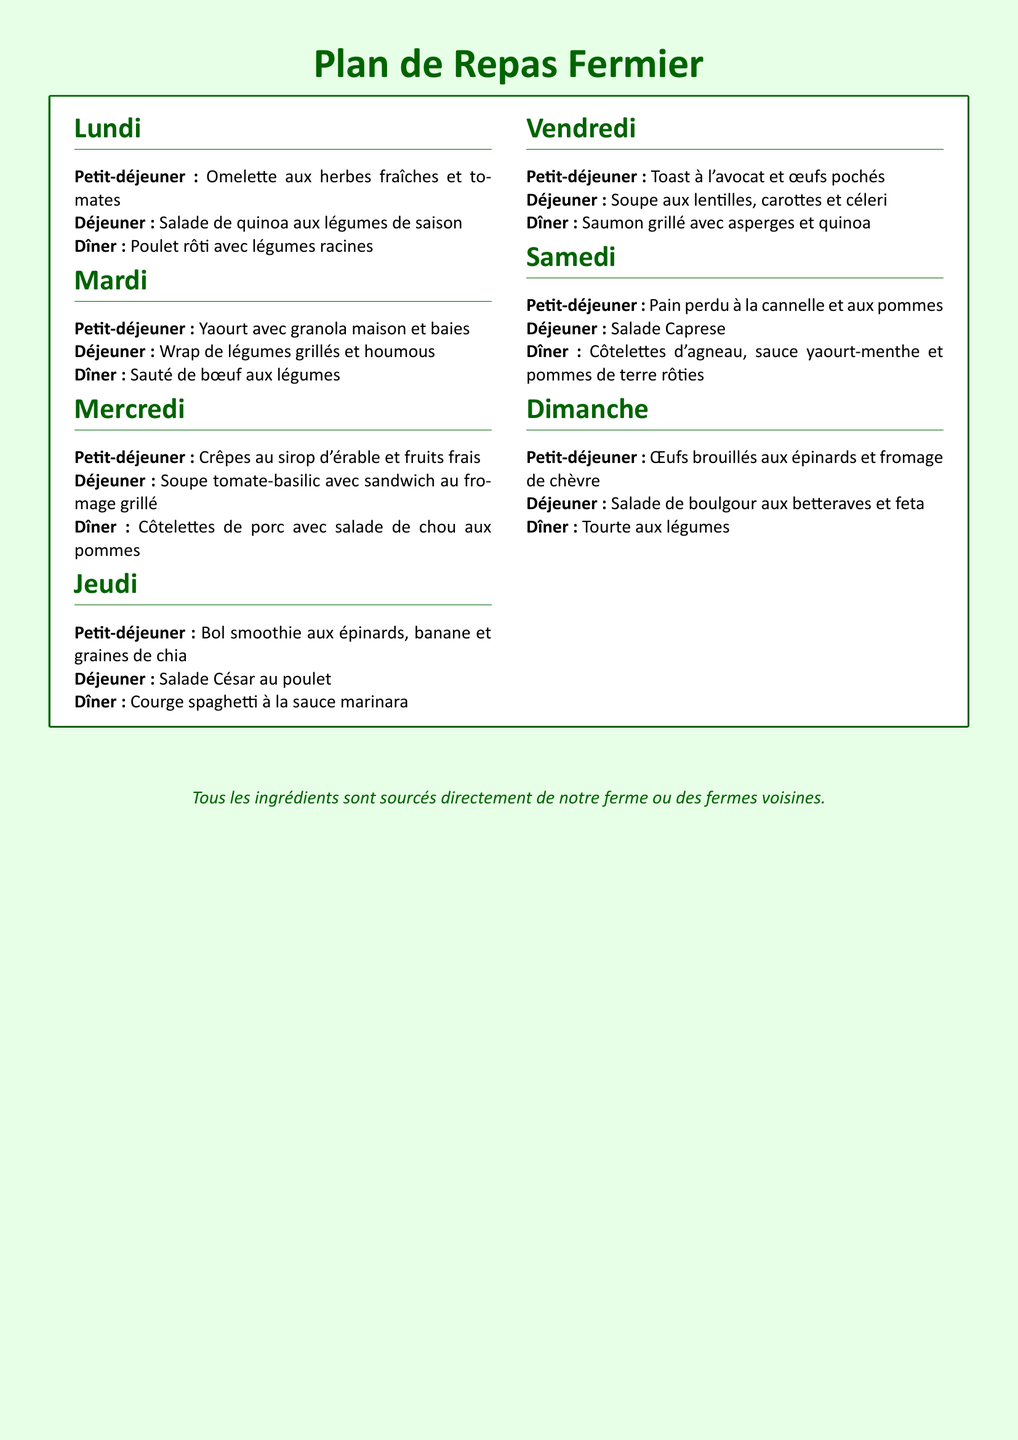Quel est le plat du dîner le lundi ? Le plat du dîner le lundi est indiqué dans la section du lundi, qui mentionne "Poulet rôti avec légumes racines".
Answer: Poulet rôti avec légumes racines Quels jours il y a une soupe dans le plan de repas ? Le plan de repas mentionne une soupe au déjeuner le mercredi et le vendredi.
Answer: Mercredi, Vendredi Quel est le petit-déjeuner du samedi ? Le petit-déjeuner du samedi est indiqué dans la section du samedi, qui mentionne "Pain perdu à la cannelle et aux pommes".
Answer: Pain perdu à la cannelle et aux pommes Combien de jours sont proposés dans ce plan de repas ? Le document contient un plan de repas pour chaque jour de la semaine, soit sept jours.
Answer: Sept Quel type de légumes est utilisé dans la salade du vendredi ? La salade du vendredi utilise des lentilles, des carottes et du céleri selon le plat mentionné dans la section du vendredi.
Answer: Lentilles, carottes et céleri Quel ingrédient est commun dans le petit-déjeuner du lundi et du mercredi ? Les deux plats du petit-déjeuner comprennent des produits frais, comme des herbes et des fruits.
Answer: Produits frais Quel type de protéine est servi au dîner le jeudi ? La section du jeudi mentionne que le dîner est "Courge spaghetti à la sauce marinara", sans protéine animale.
Answer: Aucune protéine animale Quel est le plat du dîner le dimanche ? Le plat du dîner le dimanche est indiqué dans la section du dimanche, qui mentionne "Tourte aux légumes".
Answer: Tourte aux légumes 